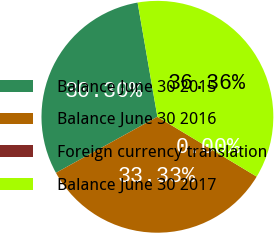<chart> <loc_0><loc_0><loc_500><loc_500><pie_chart><fcel>Balance June 30 2015<fcel>Balance June 30 2016<fcel>Foreign currency translation<fcel>Balance June 30 2017<nl><fcel>30.3%<fcel>33.33%<fcel>0.0%<fcel>36.36%<nl></chart> 